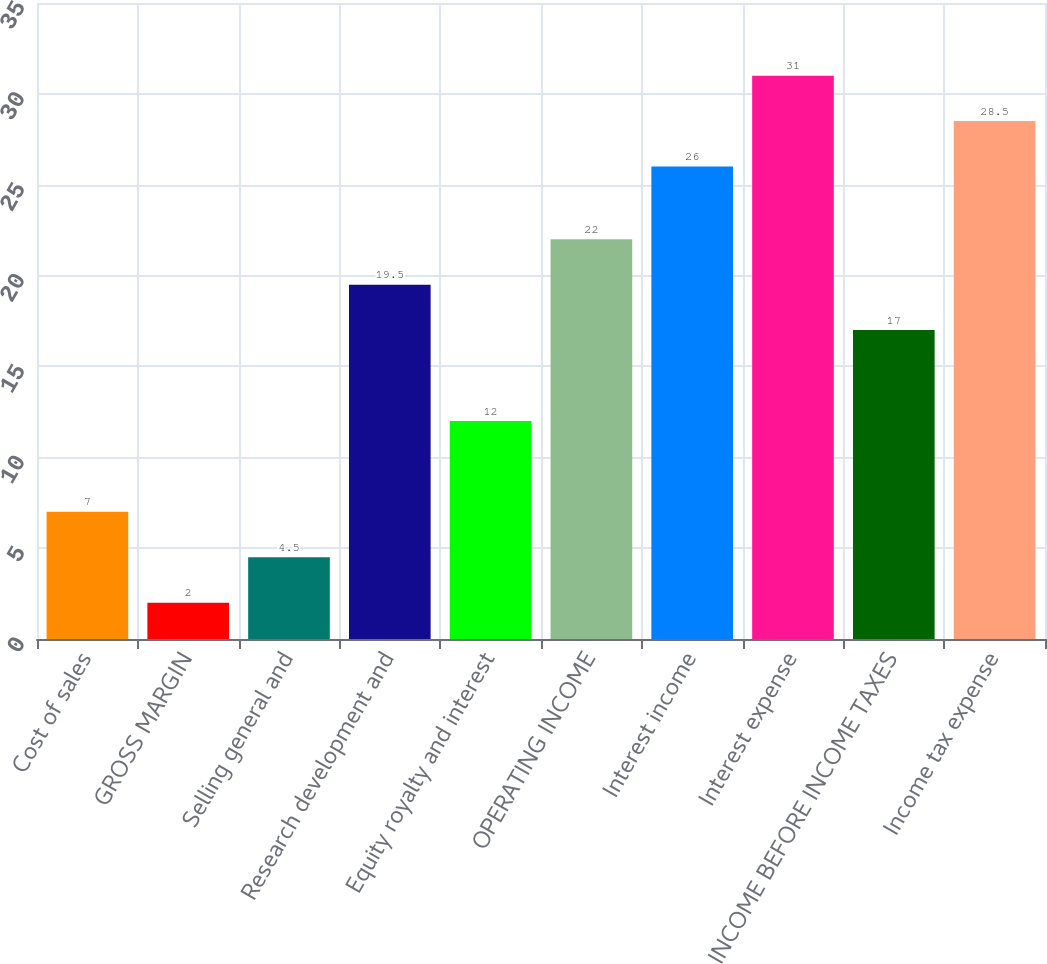<chart> <loc_0><loc_0><loc_500><loc_500><bar_chart><fcel>Cost of sales<fcel>GROSS MARGIN<fcel>Selling general and<fcel>Research development and<fcel>Equity royalty and interest<fcel>OPERATING INCOME<fcel>Interest income<fcel>Interest expense<fcel>INCOME BEFORE INCOME TAXES<fcel>Income tax expense<nl><fcel>7<fcel>2<fcel>4.5<fcel>19.5<fcel>12<fcel>22<fcel>26<fcel>31<fcel>17<fcel>28.5<nl></chart> 